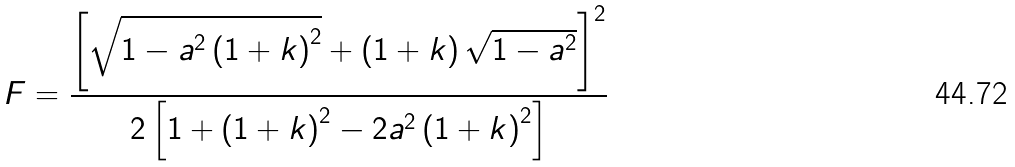Convert formula to latex. <formula><loc_0><loc_0><loc_500><loc_500>F = \frac { \left [ \sqrt { 1 - a ^ { 2 } \left ( 1 + k \right ) ^ { 2 } } + \left ( 1 + k \right ) \sqrt { 1 - a ^ { 2 } } \right ] ^ { 2 } } { 2 \left [ 1 + \left ( 1 + k \right ) ^ { 2 } - 2 a ^ { 2 } \left ( 1 + k \right ) ^ { 2 } \right ] }</formula> 